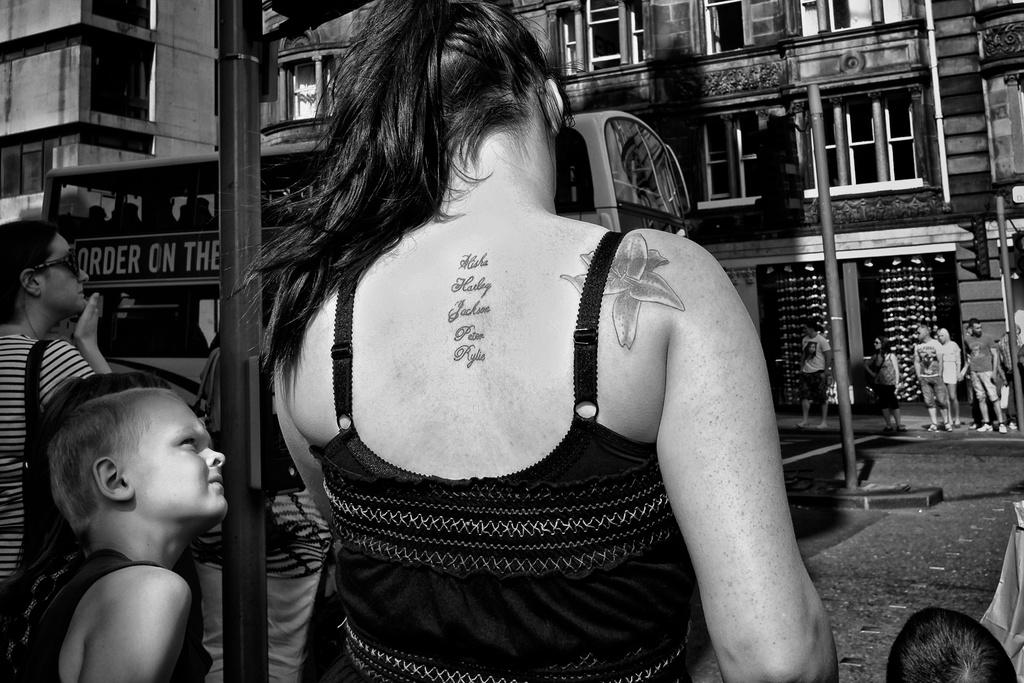Who can be seen in the foreground of the image? There are two ladies and kids in the foreground of the image. What is happening in the background of the image? A bus is moving on the road in the image, and there are people standing in the background. What type of structures can be seen in the background of the image? There are buildings in the background of the image. What type of fork can be seen in the image? There is no fork present in the image; it features a bus moving on the road and people standing in the background. 